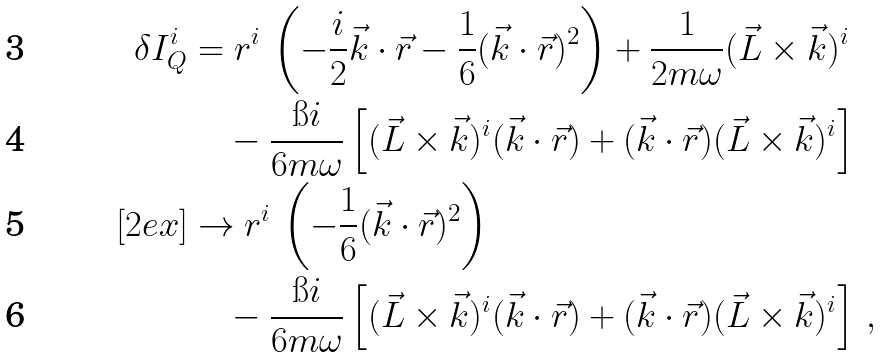Convert formula to latex. <formula><loc_0><loc_0><loc_500><loc_500>\delta I ^ { i } _ { Q } & = r ^ { i } \, \left ( - \frac { i } { 2 } \vec { k } \cdot \vec { r } - \frac { 1 } { 6 } ( \vec { k } \cdot \vec { r } ) ^ { 2 } \right ) + \frac { 1 } { 2 m \omega } ( \vec { L } \times \vec { k } ) ^ { i } \\ & \quad - \frac { \i i } { 6 m \omega } \left [ ( \vec { L } \times \vec { k } ) ^ { i } ( \vec { k } \cdot \vec { r } ) + ( \vec { k } \cdot \vec { r } ) ( \vec { L } \times \vec { k } ) ^ { i } \right ] \\ [ 2 e x ] & \to r ^ { i } \, \left ( - \frac { 1 } { 6 } ( \vec { k } \cdot \vec { r } ) ^ { 2 } \right ) \\ & \quad - \frac { \i i } { 6 m \omega } \left [ ( \vec { L } \times \vec { k } ) ^ { i } ( \vec { k } \cdot \vec { r } ) + ( \vec { k } \cdot \vec { r } ) ( \vec { L } \times \vec { k } ) ^ { i } \right ] \, ,</formula> 